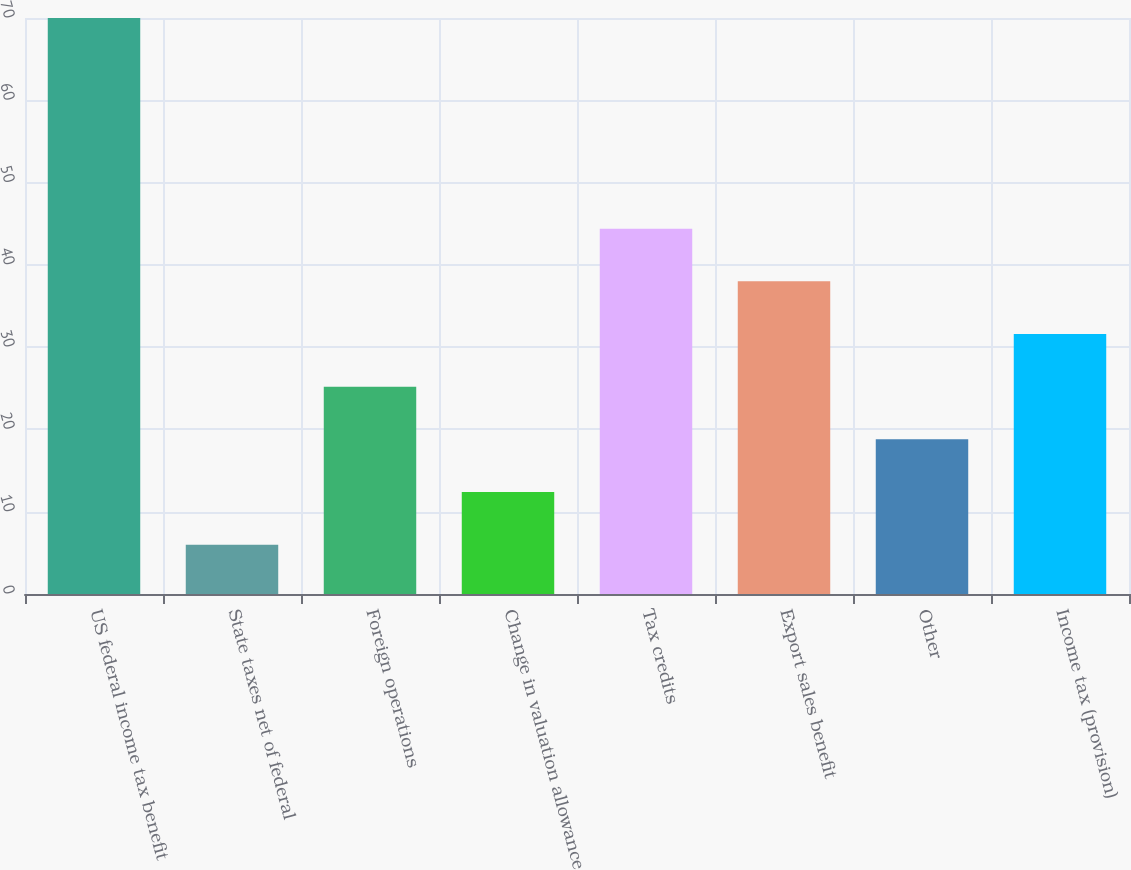Convert chart. <chart><loc_0><loc_0><loc_500><loc_500><bar_chart><fcel>US federal income tax benefit<fcel>State taxes net of federal<fcel>Foreign operations<fcel>Change in valuation allowance<fcel>Tax credits<fcel>Export sales benefit<fcel>Other<fcel>Income tax (provision)<nl><fcel>70<fcel>6<fcel>25.2<fcel>12.4<fcel>44.4<fcel>38<fcel>18.8<fcel>31.6<nl></chart> 